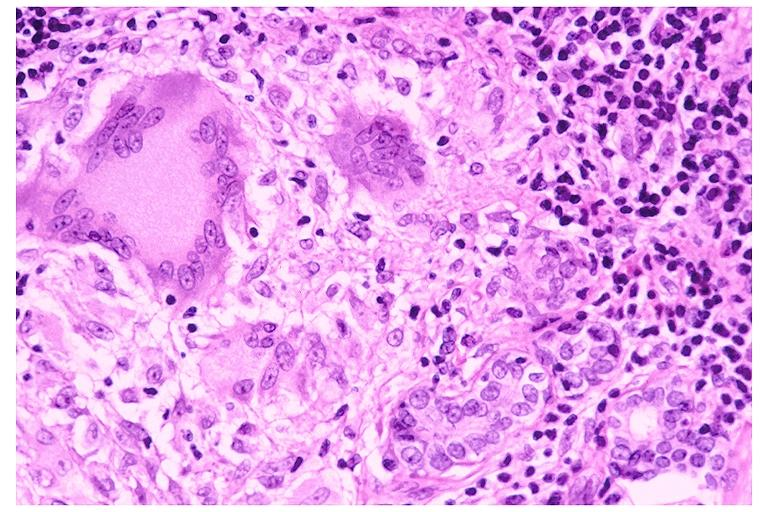s oral present?
Answer the question using a single word or phrase. Yes 